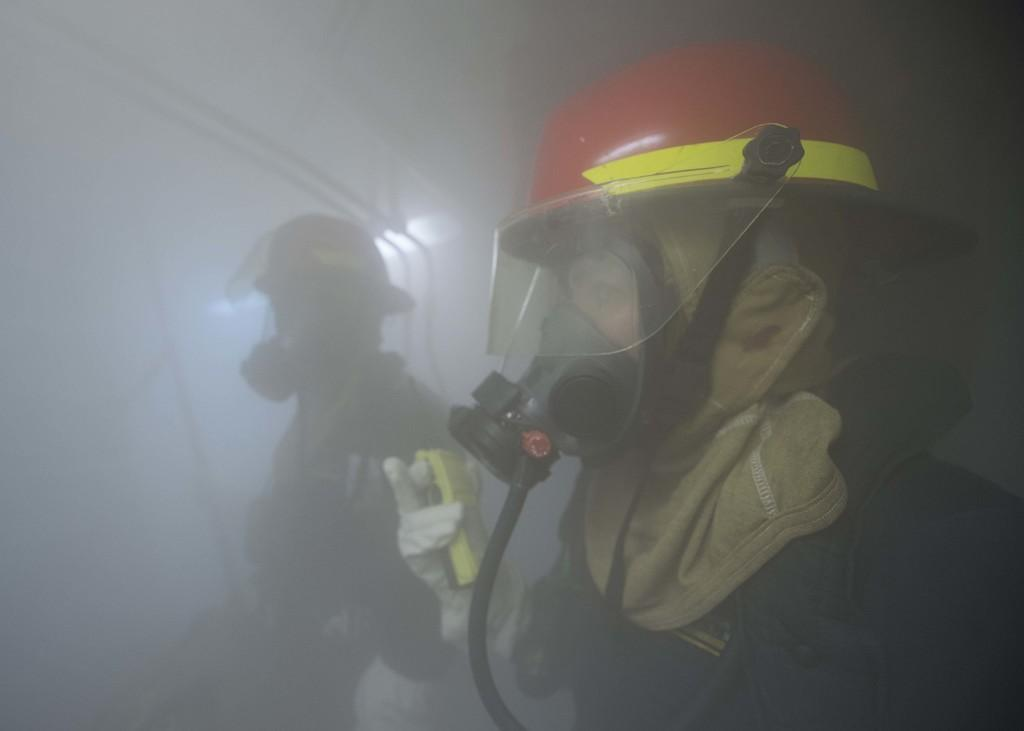How many people are in the image? There are two persons in the image. What are the persons wearing on their faces? The persons are wearing oxygen masks. What else are the persons wearing in the image? The persons are wearing helmets. What can be seen in the background of the image? There is smoke visible in the background of the image. What type of leather is being used to make the nail in the image? There is no leather or nail present in the image. 